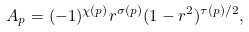Convert formula to latex. <formula><loc_0><loc_0><loc_500><loc_500>A _ { p } = ( - 1 ) ^ { \chi ( p ) } r ^ { \sigma ( p ) } ( 1 - r ^ { 2 } ) ^ { \tau ( p ) / 2 } ,</formula> 